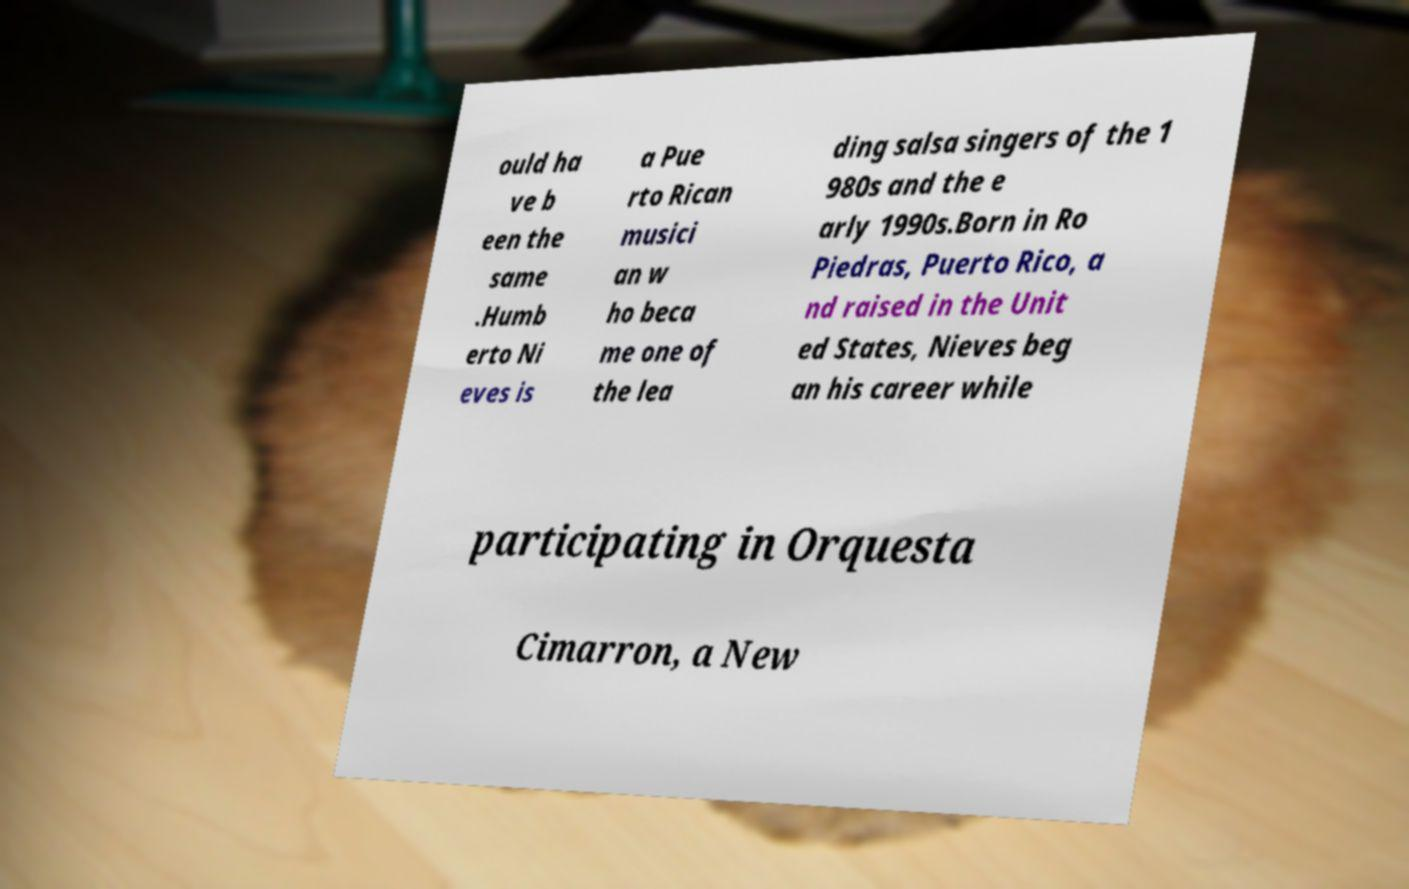There's text embedded in this image that I need extracted. Can you transcribe it verbatim? ould ha ve b een the same .Humb erto Ni eves is a Pue rto Rican musici an w ho beca me one of the lea ding salsa singers of the 1 980s and the e arly 1990s.Born in Ro Piedras, Puerto Rico, a nd raised in the Unit ed States, Nieves beg an his career while participating in Orquesta Cimarron, a New 